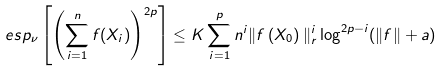Convert formula to latex. <formula><loc_0><loc_0><loc_500><loc_500>\ e s p _ { \nu } \left [ \left ( \sum _ { i = 1 } ^ { n } f ( X _ { i } ) \right ) ^ { 2 p } \right ] \leq K \sum _ { i = 1 } ^ { p } n ^ { i } \| f \left ( X _ { 0 } \right ) \| _ { r } ^ { i } \log ^ { 2 p - i } ( \| f \| + a )</formula> 